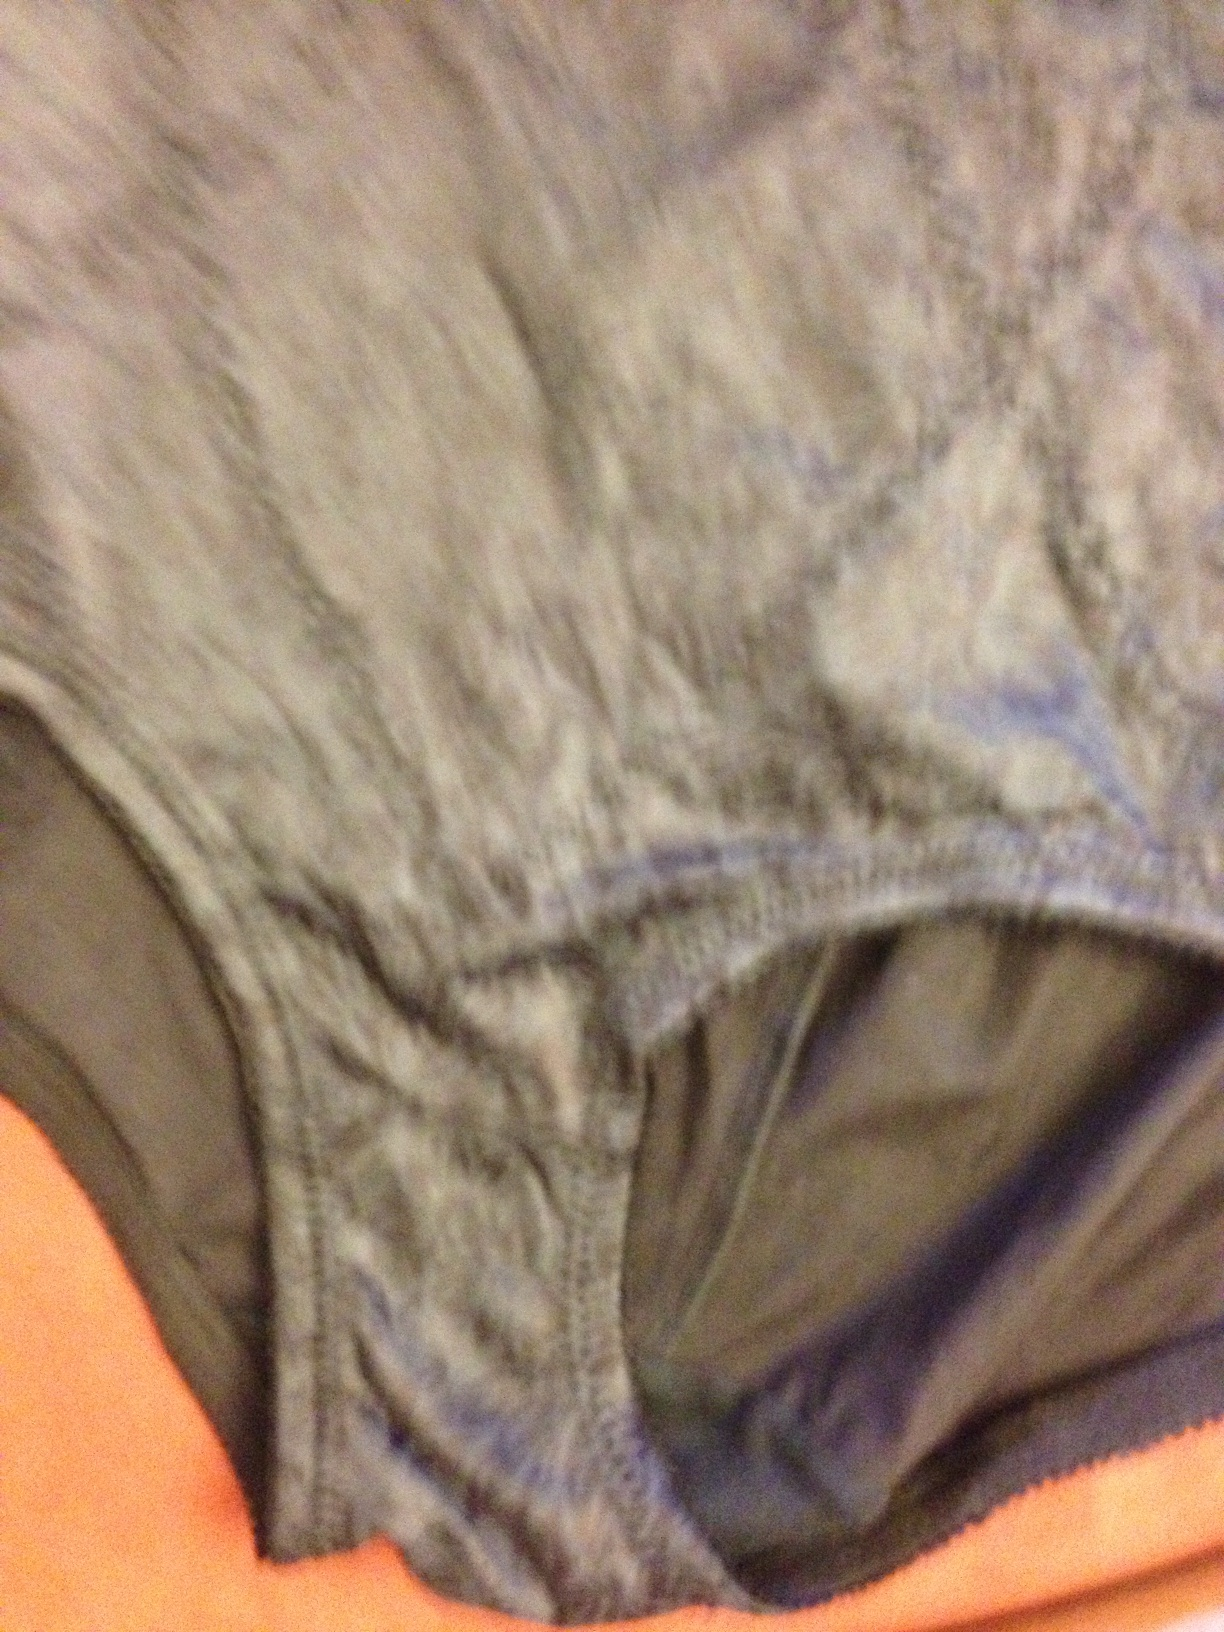Can you describe the material of the item shown in this image? The material appears to be a soft, stretchable fabric typically used in underwear, likely a cotton blend with some elastane for flexibility. 